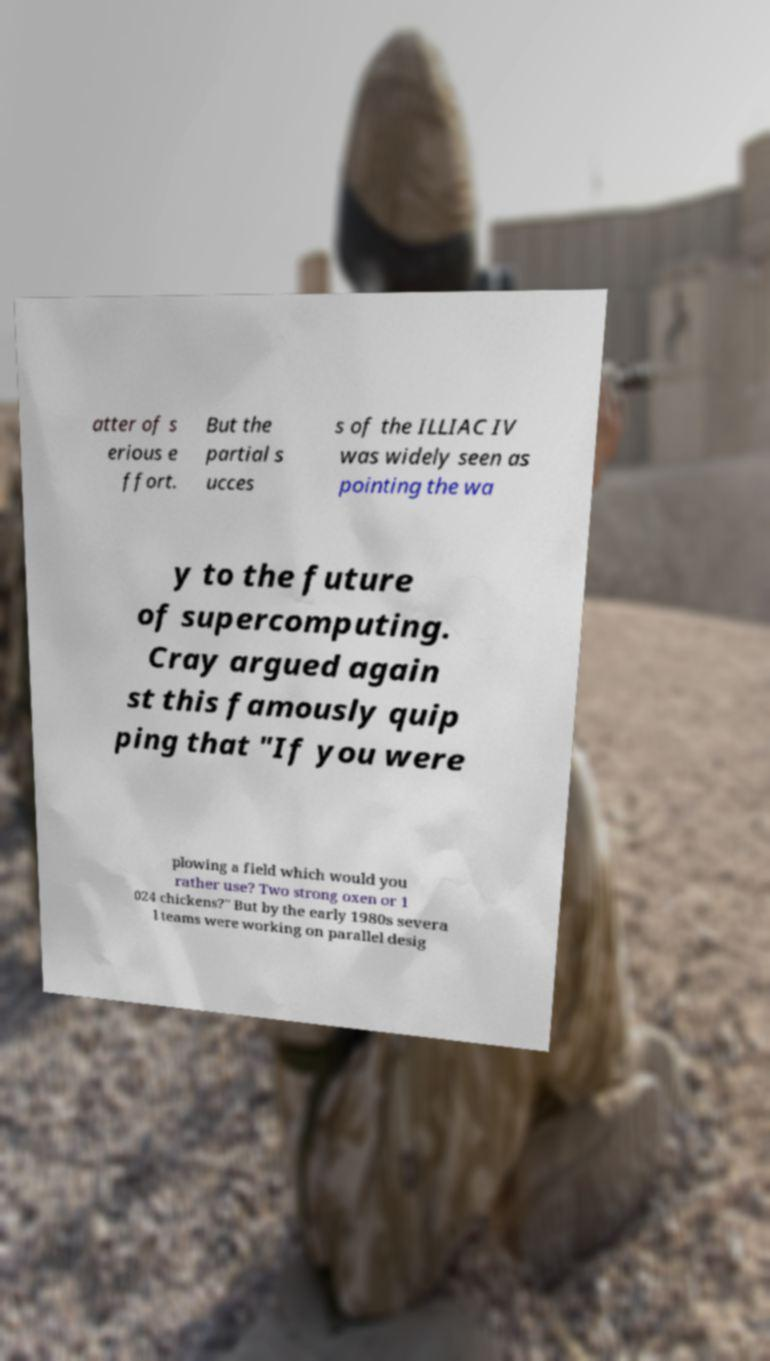Please read and relay the text visible in this image. What does it say? atter of s erious e ffort. But the partial s ucces s of the ILLIAC IV was widely seen as pointing the wa y to the future of supercomputing. Cray argued again st this famously quip ping that "If you were plowing a field which would you rather use? Two strong oxen or 1 024 chickens?" But by the early 1980s severa l teams were working on parallel desig 